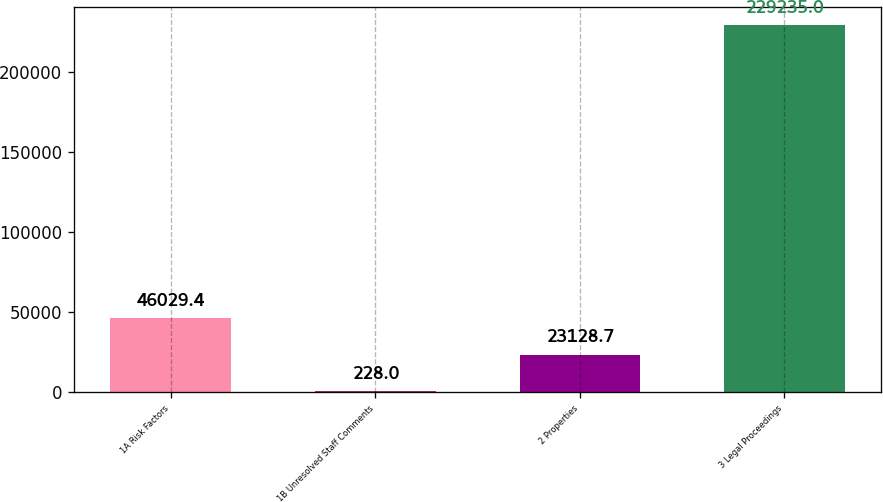Convert chart. <chart><loc_0><loc_0><loc_500><loc_500><bar_chart><fcel>1A Risk Factors<fcel>1B Unresolved Staff Comments<fcel>2 Properties<fcel>3 Legal Proceedings<nl><fcel>46029.4<fcel>228<fcel>23128.7<fcel>229235<nl></chart> 